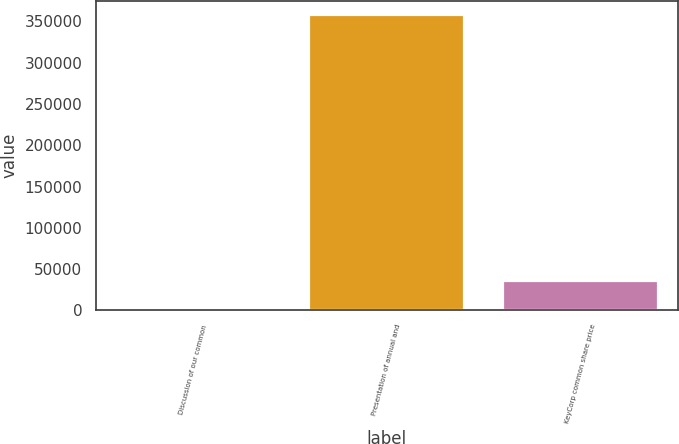<chart> <loc_0><loc_0><loc_500><loc_500><bar_chart><fcel>Discussion of our common<fcel>Presentation of annual and<fcel>KeyCorp common share price<nl><fcel>69<fcel>356997<fcel>35761.8<nl></chart> 